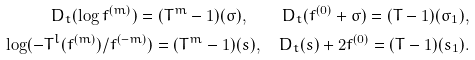Convert formula to latex. <formula><loc_0><loc_0><loc_500><loc_500>D _ { t } ( \log f ^ { ( m ) } ) = ( T ^ { m } - 1 ) ( \sigma ) , \quad D _ { t } ( f ^ { ( 0 ) } + \sigma ) = ( T - 1 ) ( \sigma _ { 1 } ) , \\ \log ( - T ^ { l } ( f ^ { ( m ) } ) / f ^ { ( - m ) } ) = ( T ^ { m } - 1 ) ( s ) , \quad D _ { t } ( s ) + 2 f ^ { ( 0 ) } = ( T - 1 ) ( s _ { 1 } ) .</formula> 